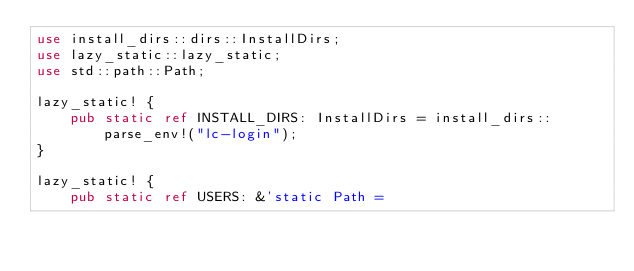Convert code to text. <code><loc_0><loc_0><loc_500><loc_500><_Rust_>use install_dirs::dirs::InstallDirs;
use lazy_static::lazy_static;
use std::path::Path;

lazy_static! {
    pub static ref INSTALL_DIRS: InstallDirs = install_dirs::parse_env!("lc-login");
}

lazy_static! {
    pub static ref USERS: &'static Path =</code> 